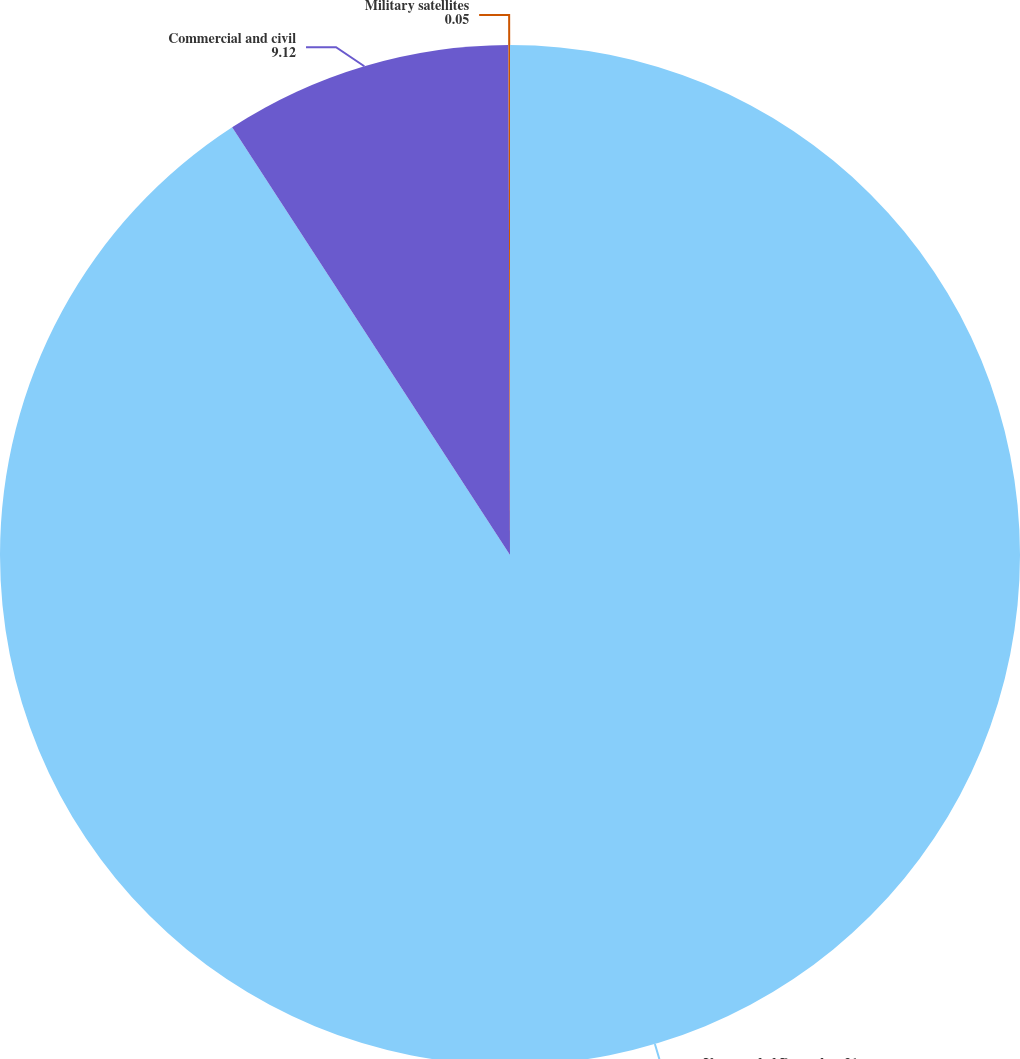Convert chart. <chart><loc_0><loc_0><loc_500><loc_500><pie_chart><fcel>Years ended December 31<fcel>Commercial and civil<fcel>Military satellites<nl><fcel>90.83%<fcel>9.12%<fcel>0.05%<nl></chart> 